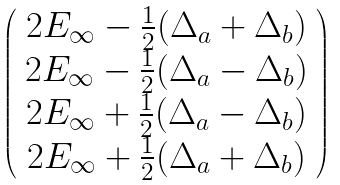<formula> <loc_0><loc_0><loc_500><loc_500>\left ( \begin{array} { c } 2 E _ { \infty } - \frac { 1 } { 2 } ( \Delta _ { a } + \Delta _ { b } ) \\ 2 E _ { \infty } - \frac { 1 } { 2 } ( \Delta _ { a } - \Delta _ { b } ) \\ 2 E _ { \infty } + \frac { 1 } { 2 } ( \Delta _ { a } - \Delta _ { b } ) \\ 2 E _ { \infty } + \frac { 1 } { 2 } ( \Delta _ { a } + \Delta _ { b } ) \end{array} \right )</formula> 